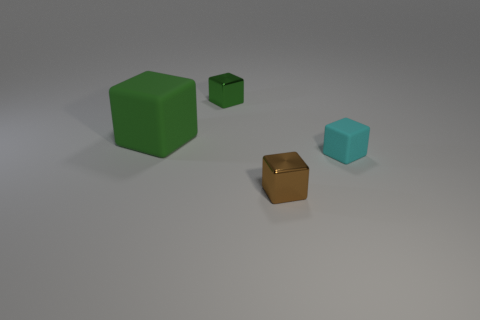Subtract 1 cubes. How many cubes are left? 3 Add 2 brown metallic blocks. How many objects exist? 6 Add 3 large matte things. How many large matte things exist? 4 Subtract 0 brown cylinders. How many objects are left? 4 Subtract all red matte objects. Subtract all cyan matte objects. How many objects are left? 3 Add 3 small green metal cubes. How many small green metal cubes are left? 4 